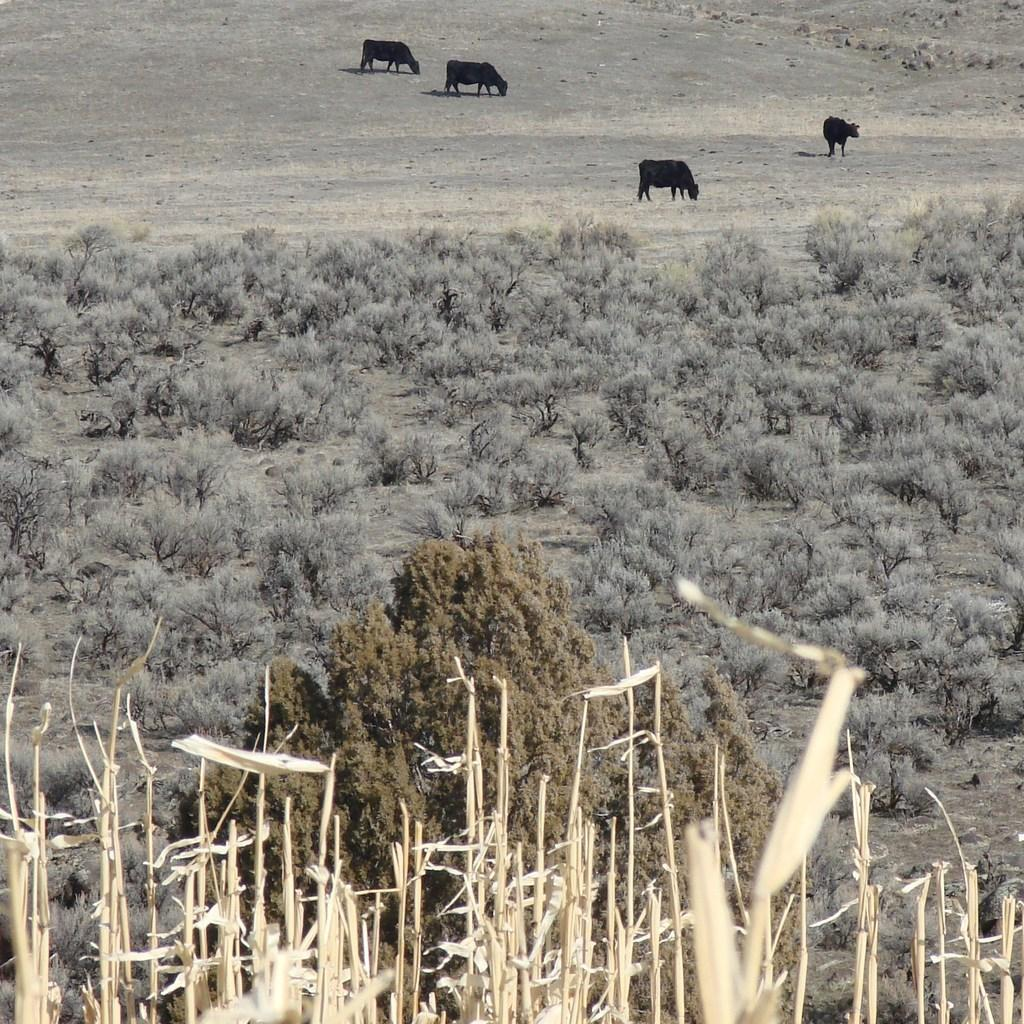What type of vegetation can be seen in the image? There are small plants and trees in the image. What else can be seen on the ground in the image? There are animals on the ground in the image. What type of milk is being served to the animals in the image? There is no milk or any indication of animals being served food in the image. 